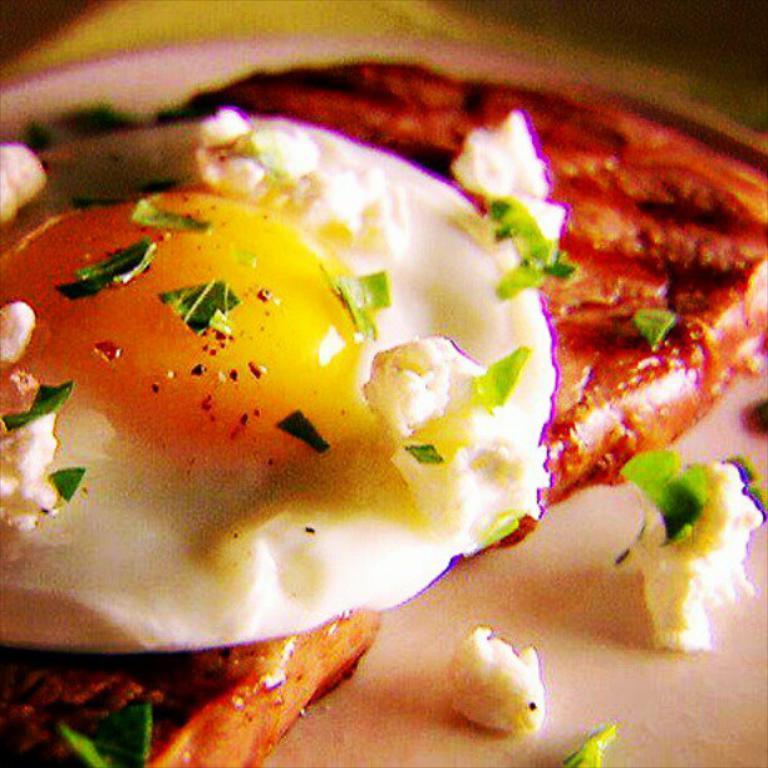Please provide a concise description of this image. This is a zoomed in picture. In the center we can see a half boiled egg and some food items. 